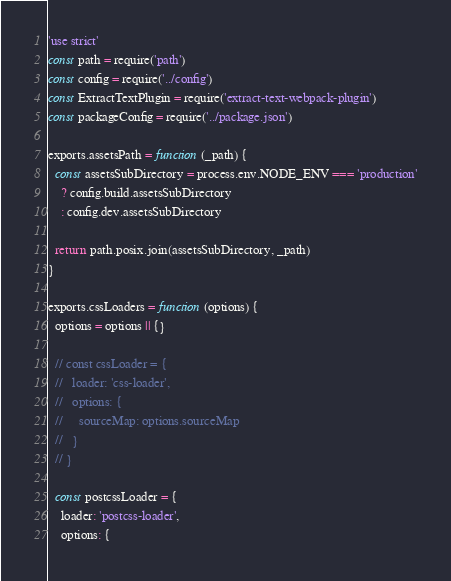Convert code to text. <code><loc_0><loc_0><loc_500><loc_500><_JavaScript_>'use strict'
const path = require('path')
const config = require('../config')
const ExtractTextPlugin = require('extract-text-webpack-plugin')
const packageConfig = require('../package.json')

exports.assetsPath = function (_path) {
  const assetsSubDirectory = process.env.NODE_ENV === 'production'
    ? config.build.assetsSubDirectory
    : config.dev.assetsSubDirectory

  return path.posix.join(assetsSubDirectory, _path)
}

exports.cssLoaders = function (options) {
  options = options || {}

  // const cssLoader = {
  //   loader: 'css-loader',
  //   options: {
  //     sourceMap: options.sourceMap
  //   }
  // }

  const postcssLoader = {
    loader: 'postcss-loader',
    options: {</code> 